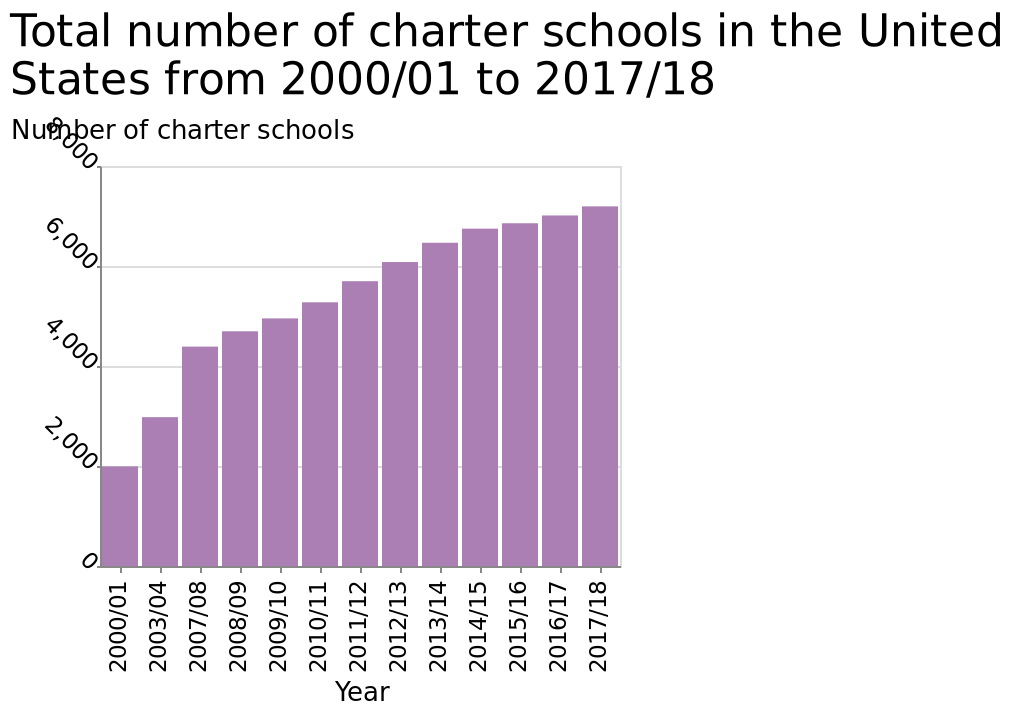<image>
By what factor did the number of charter schools increase between 2000/01 and 2017/18?  The number of charter schools increased by almost 3.5 times between 2000/01 and 2017/18, as shown by the bar diagram. Has the number of charter schools been consistent throughout the years?  No, the number of charter schools has increased continually, according to the bar diagram. 